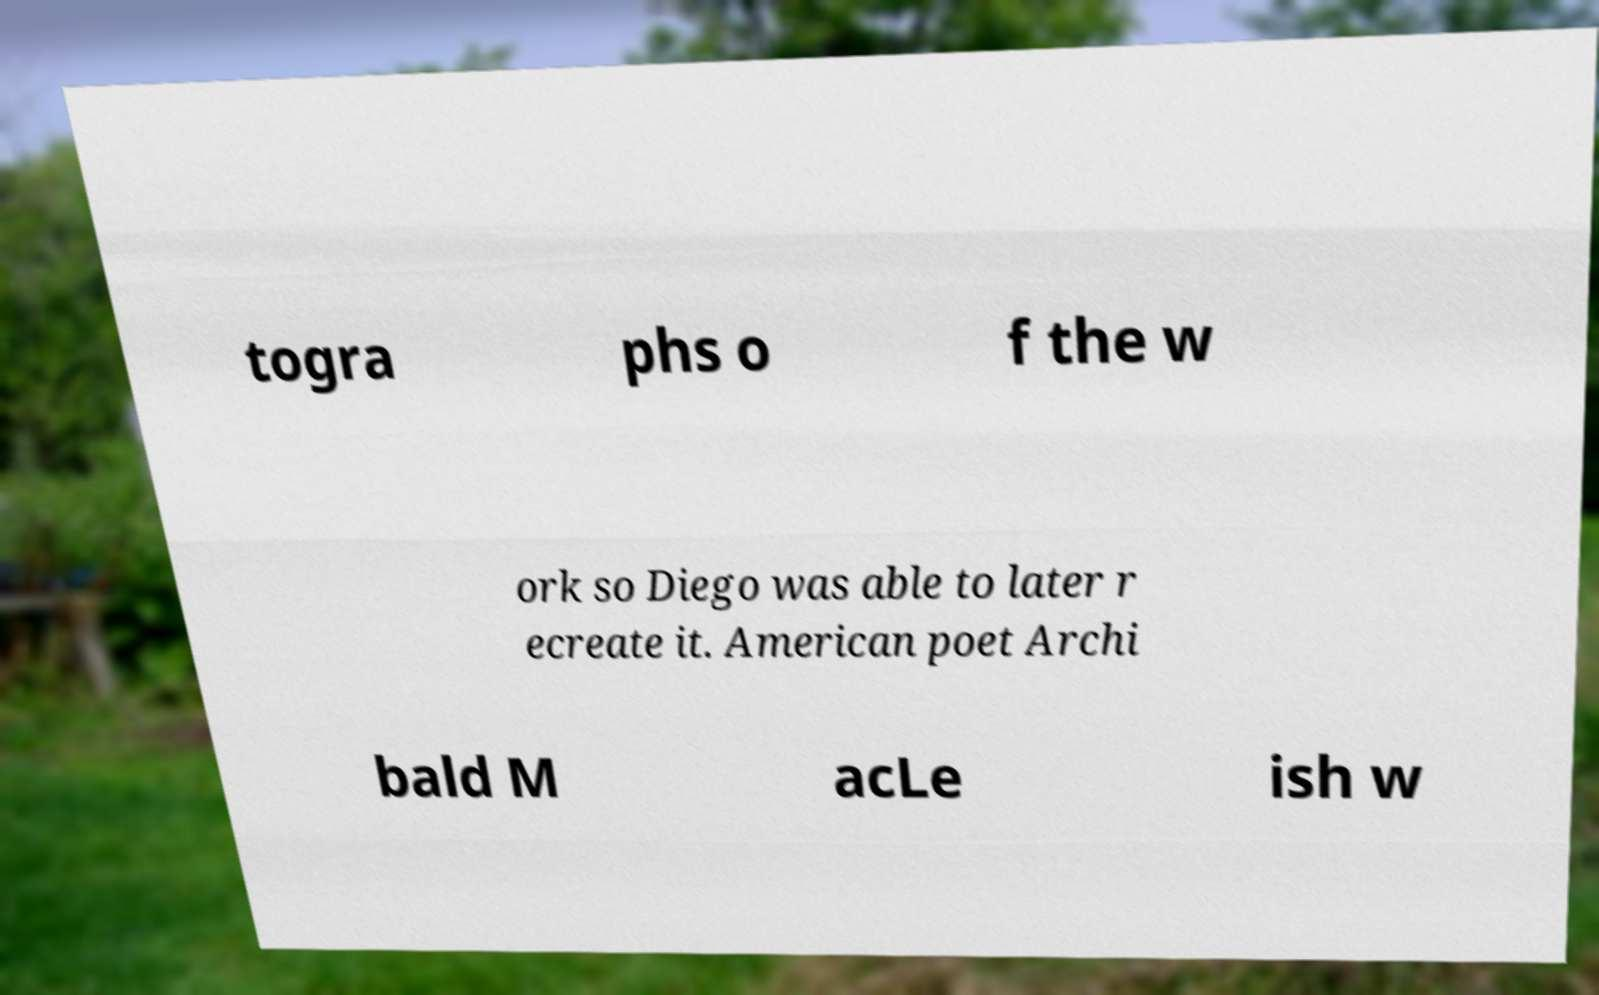Please read and relay the text visible in this image. What does it say? togra phs o f the w ork so Diego was able to later r ecreate it. American poet Archi bald M acLe ish w 